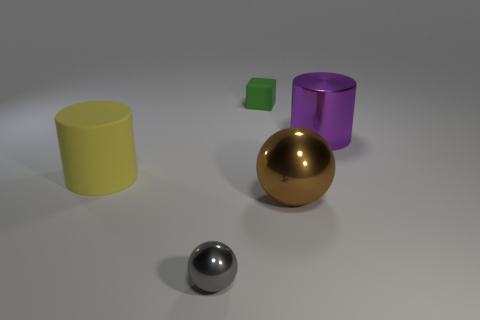What different colors are present in the image? The image presents a variety of colors: there's a yellow cylindrical object, a green cube, a purple cylinder, a gold sphere, and a chrome sphere that reflects the surroundings. 